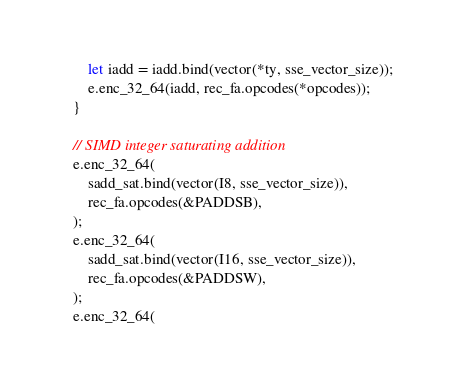<code> <loc_0><loc_0><loc_500><loc_500><_Rust_>        let iadd = iadd.bind(vector(*ty, sse_vector_size));
        e.enc_32_64(iadd, rec_fa.opcodes(*opcodes));
    }

    // SIMD integer saturating addition
    e.enc_32_64(
        sadd_sat.bind(vector(I8, sse_vector_size)),
        rec_fa.opcodes(&PADDSB),
    );
    e.enc_32_64(
        sadd_sat.bind(vector(I16, sse_vector_size)),
        rec_fa.opcodes(&PADDSW),
    );
    e.enc_32_64(</code> 